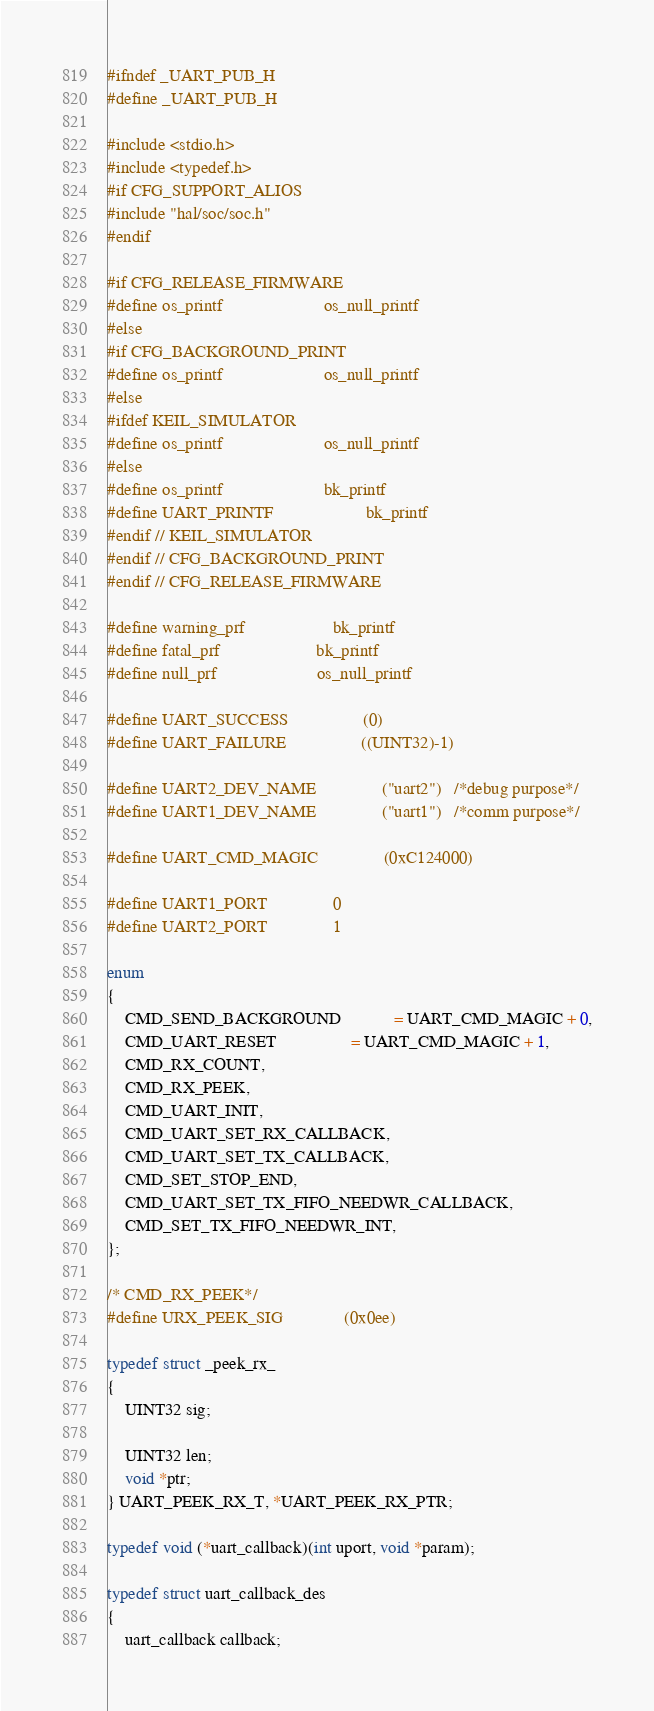Convert code to text. <code><loc_0><loc_0><loc_500><loc_500><_C_>#ifndef _UART_PUB_H
#define _UART_PUB_H

#include <stdio.h>
#include <typedef.h>
#if CFG_SUPPORT_ALIOS
#include "hal/soc/soc.h"
#endif

#if CFG_RELEASE_FIRMWARE
#define os_printf                       os_null_printf
#else
#if CFG_BACKGROUND_PRINT
#define os_printf                       os_null_printf
#else
#ifdef KEIL_SIMULATOR
#define os_printf                       os_null_printf
#else
#define os_printf                       bk_printf
#define UART_PRINTF                     bk_printf
#endif // KEIL_SIMULATOR
#endif // CFG_BACKGROUND_PRINT
#endif // CFG_RELEASE_FIRMWARE

#define warning_prf                    bk_printf
#define fatal_prf                      bk_printf
#define null_prf                       os_null_printf

#define UART_SUCCESS                 (0)
#define UART_FAILURE                 ((UINT32)-1)

#define UART2_DEV_NAME               ("uart2")   /*debug purpose*/
#define UART1_DEV_NAME               ("uart1")   /*comm purpose*/

#define UART_CMD_MAGIC               (0xC124000)

#define UART1_PORT				0
#define UART2_PORT				1

enum
{
    CMD_SEND_BACKGROUND            = UART_CMD_MAGIC + 0,
    CMD_UART_RESET                 = UART_CMD_MAGIC + 1,
    CMD_RX_COUNT,
    CMD_RX_PEEK,
    CMD_UART_INIT,
    CMD_UART_SET_RX_CALLBACK,
    CMD_UART_SET_TX_CALLBACK,   
    CMD_SET_STOP_END,    
    CMD_UART_SET_TX_FIFO_NEEDWR_CALLBACK,
    CMD_SET_TX_FIFO_NEEDWR_INT,
};

/* CMD_RX_PEEK*/
#define URX_PEEK_SIG              (0x0ee)

typedef struct _peek_rx_
{
    UINT32 sig;

    UINT32 len;
    void *ptr;
} UART_PEEK_RX_T, *UART_PEEK_RX_PTR;

typedef void (*uart_callback)(int uport, void *param);

typedef struct uart_callback_des
{
    uart_callback callback;</code> 